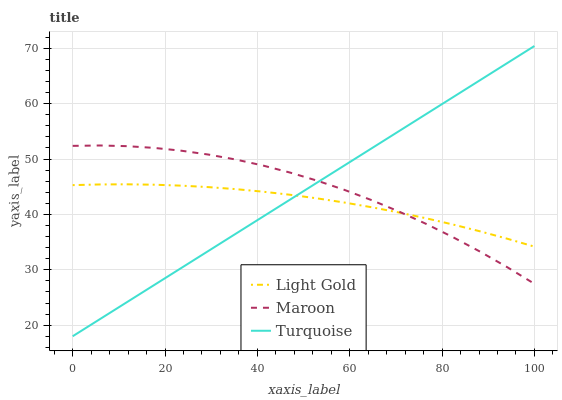Does Maroon have the minimum area under the curve?
Answer yes or no. No. Does Light Gold have the maximum area under the curve?
Answer yes or no. No. Is Light Gold the smoothest?
Answer yes or no. No. Is Light Gold the roughest?
Answer yes or no. No. Does Maroon have the lowest value?
Answer yes or no. No. Does Maroon have the highest value?
Answer yes or no. No. 